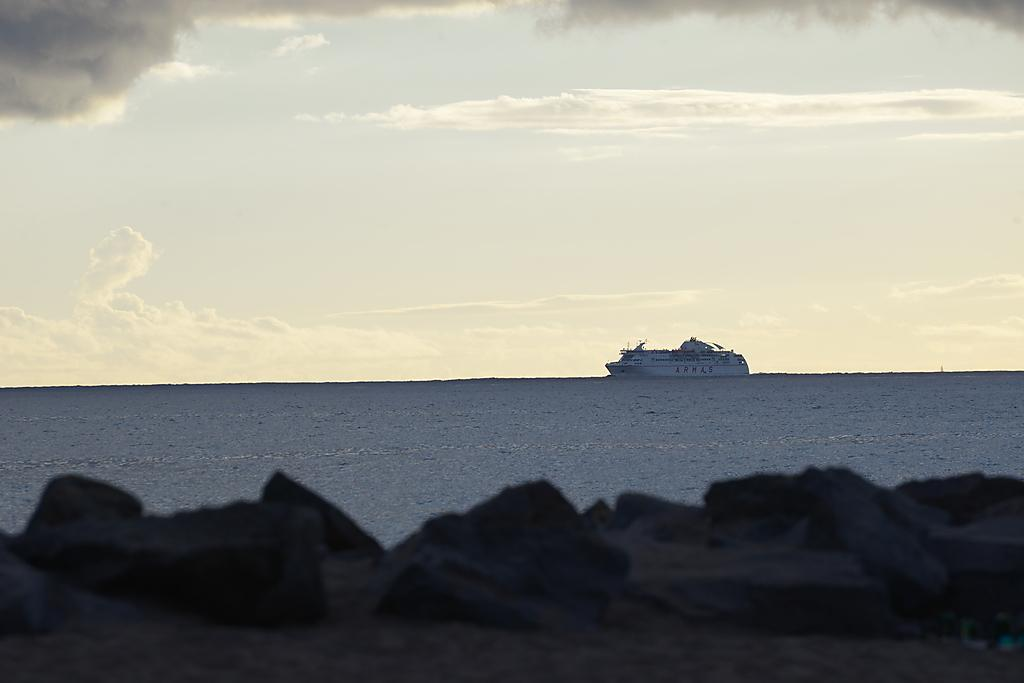What type of vehicle is in the water in the image? There is a white cruise ship in the water in the image. What can be seen in the foreground of the image? There are stones in the front of the image. What is visible in the background of the image? The sky is visible in the image. Can you describe the sky in the image? Clouds are present in the sky. How many pizzas are being delivered by the police in the image? There are no pizzas or police present in the image. 